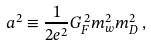Convert formula to latex. <formula><loc_0><loc_0><loc_500><loc_500>a ^ { 2 } \equiv \frac { 1 } { 2 e ^ { 2 } } G _ { F } ^ { \, 2 } m _ { w } ^ { 2 } m _ { D } ^ { 2 } \, ,</formula> 